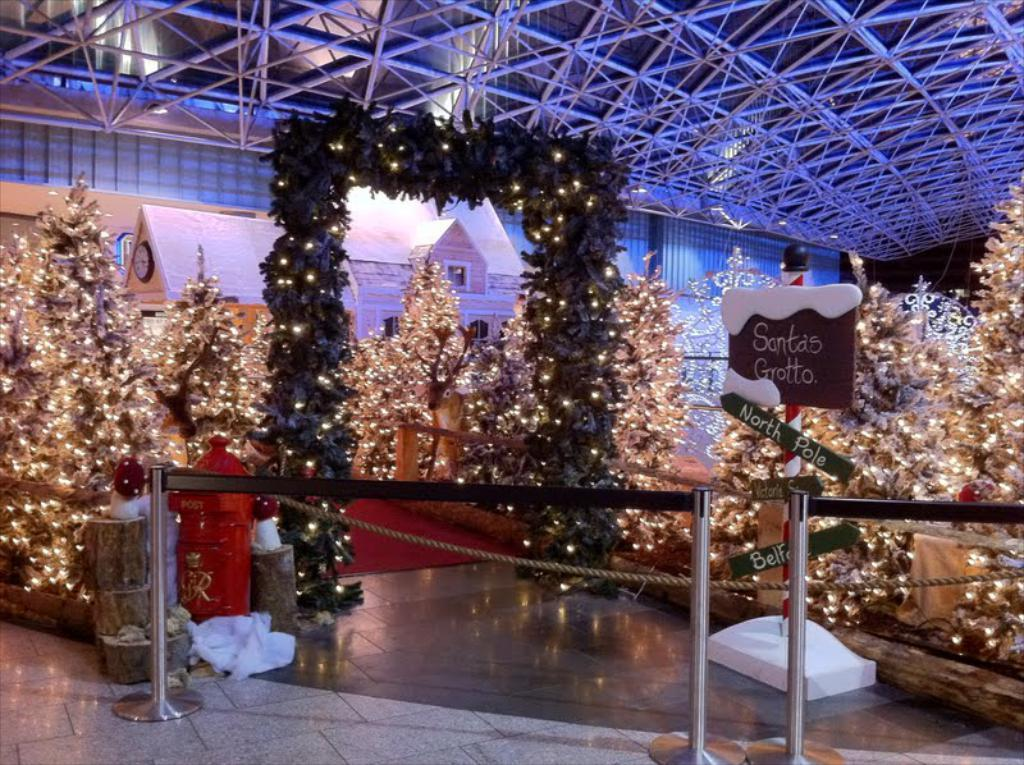What type of lighting is present in the image? There are decorative lights in the image. What can be seen to manage crowds in the image? There are crowd control barriers in the image. What type of trees are present in the image? There are Christmas trees in the image. What type of building is decorated in the image? There is a decorative house in the image. What is the cook preparing for dinner in the image? There is no cook or dinner preparation visible in the image. What is the sun's position in the image? The sun is not visible in the image, as it is a nighttime scene with decorative lights. 